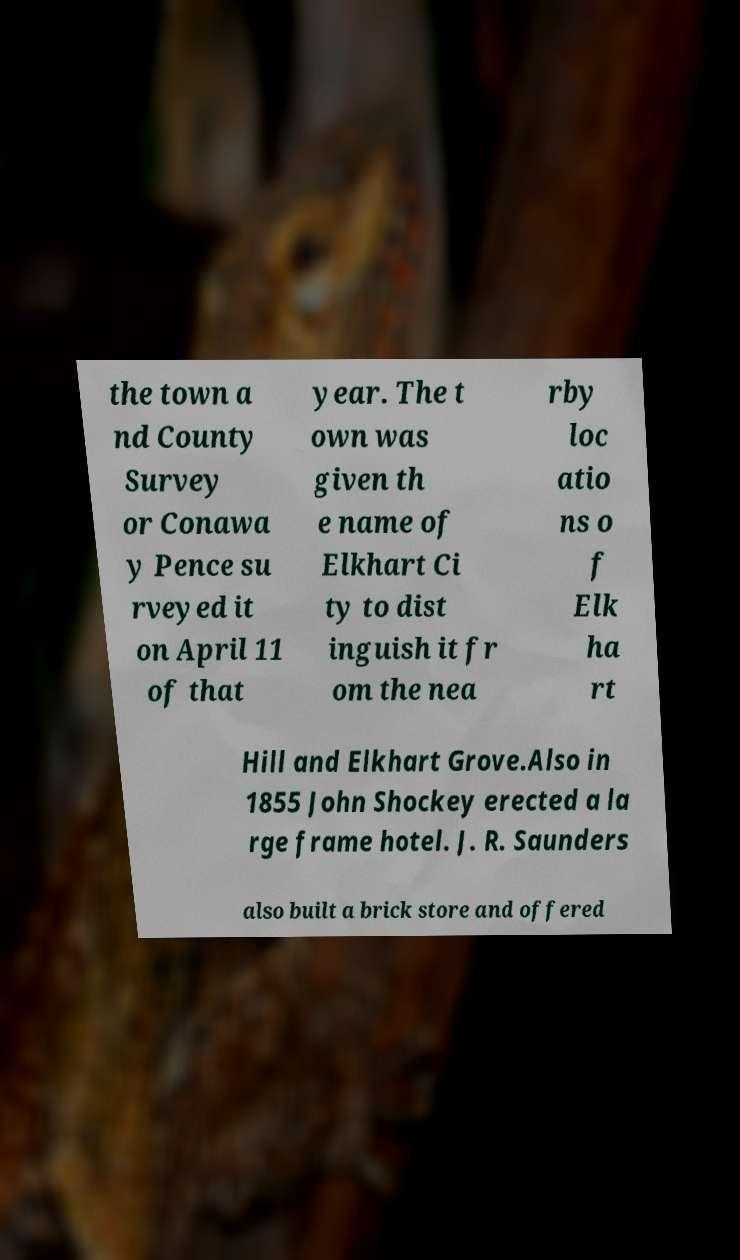Please read and relay the text visible in this image. What does it say? the town a nd County Survey or Conawa y Pence su rveyed it on April 11 of that year. The t own was given th e name of Elkhart Ci ty to dist inguish it fr om the nea rby loc atio ns o f Elk ha rt Hill and Elkhart Grove.Also in 1855 John Shockey erected a la rge frame hotel. J. R. Saunders also built a brick store and offered 